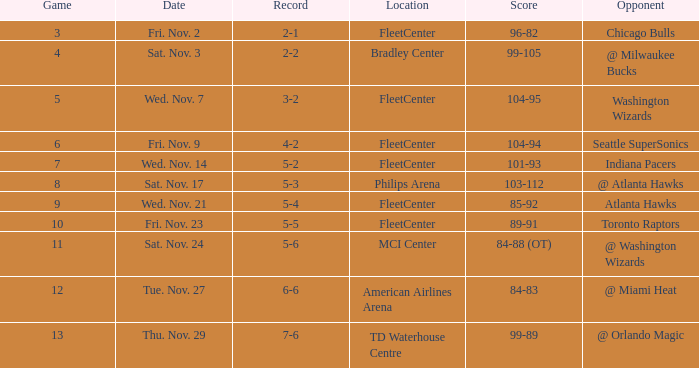On what date did Fleetcenter have a game lower than 9 with a score of 104-94? Fri. Nov. 9. 